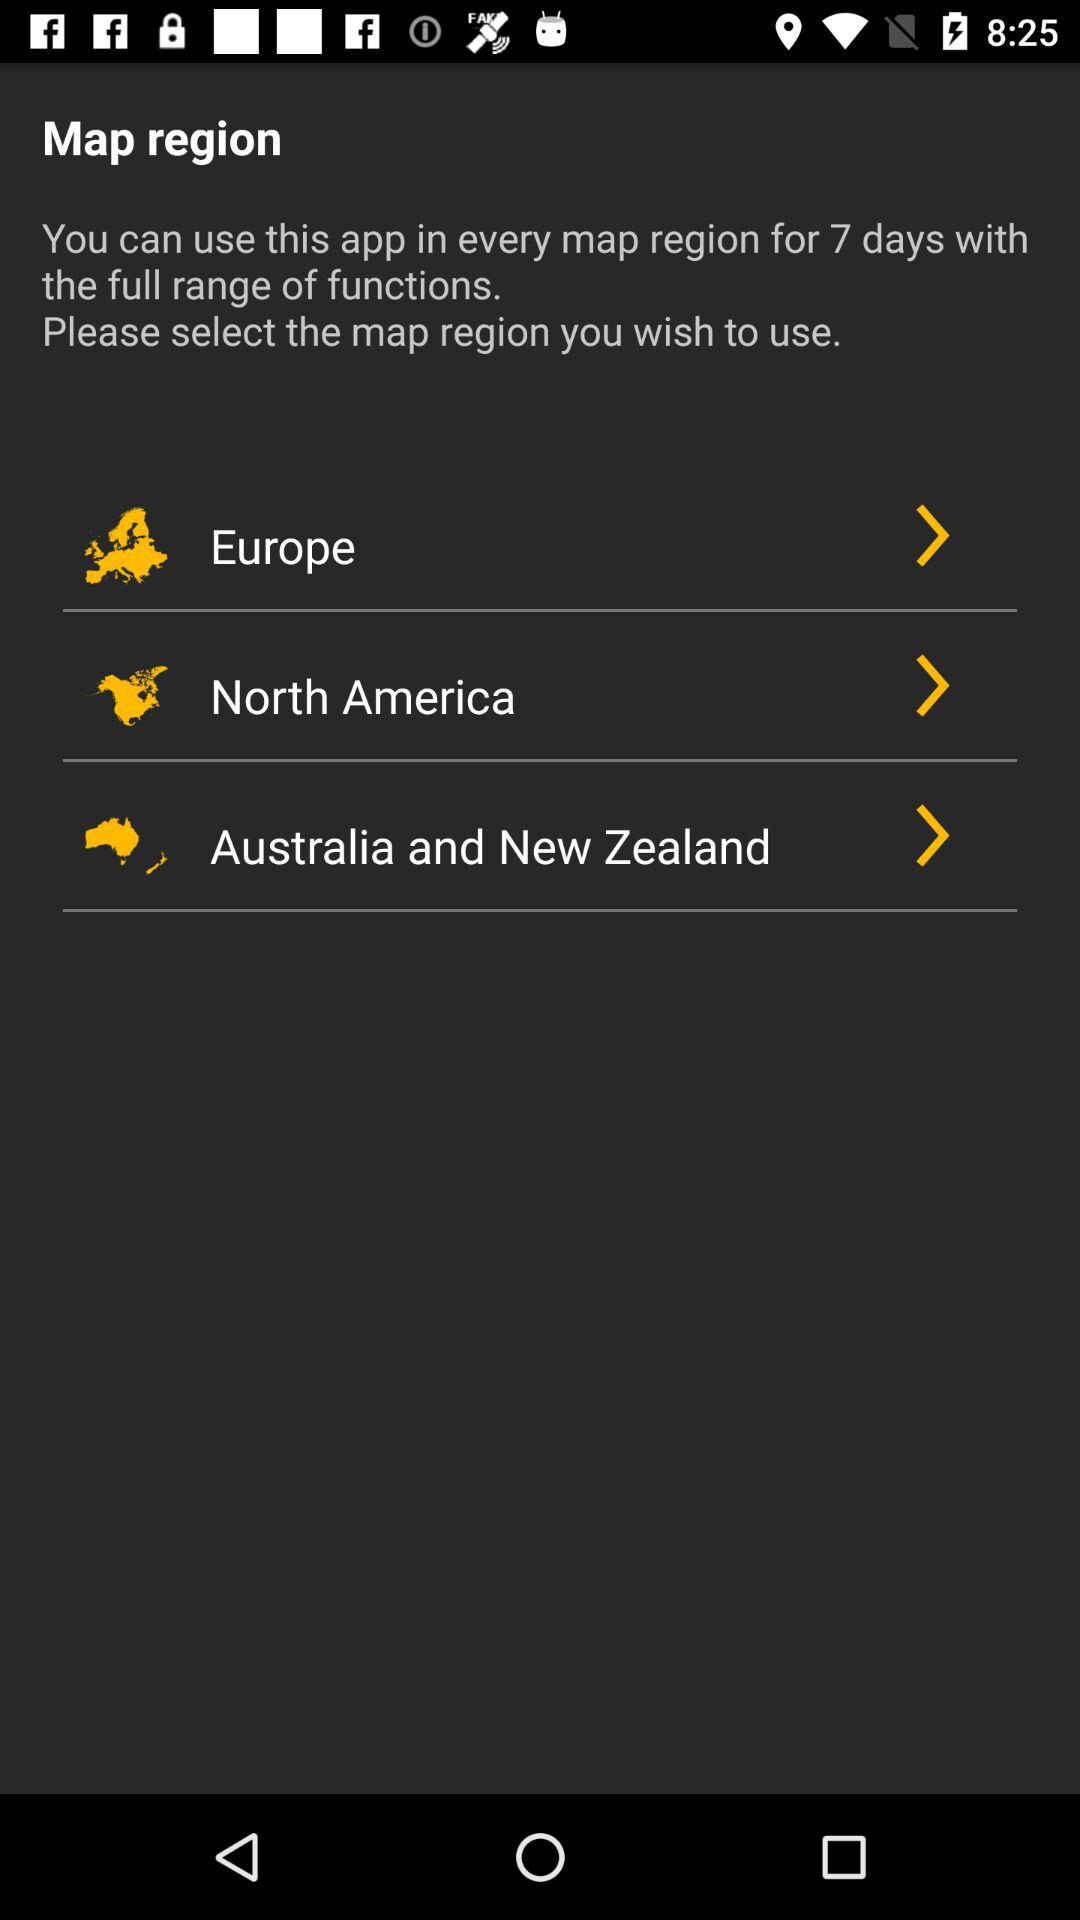How many map regions are available?
Answer the question using a single word or phrase. 3 